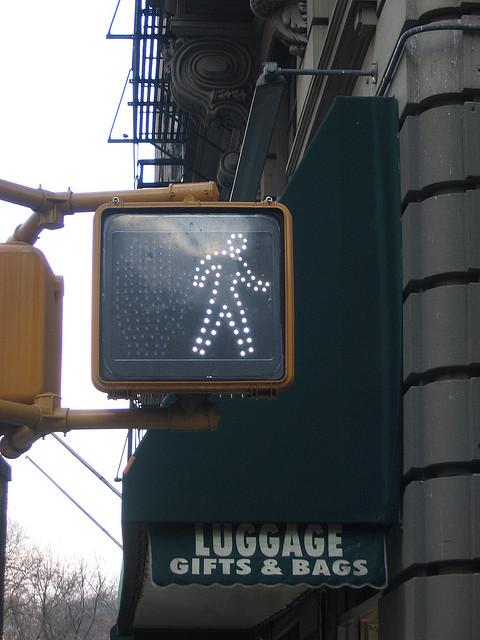Was this picture taken in summer?
Give a very brief answer. No. Is the sign don't walk or walk?
Give a very brief answer. Walk. What is the business being shown?
Keep it brief. Luggage gifts & bags. 